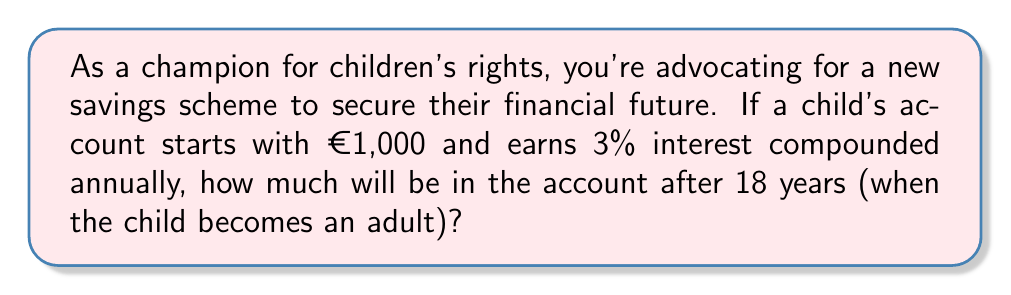Give your solution to this math problem. To solve this problem, we'll use the compound interest formula:

$$ A = P(1 + r)^n $$

Where:
$A$ = final amount
$P$ = principal (initial investment)
$r$ = annual interest rate (in decimal form)
$n$ = number of years

Given:
$P = €1,000$
$r = 3\% = 0.03$
$n = 18$ years

Let's substitute these values into the formula:

$$ A = 1000(1 + 0.03)^{18} $$

Now, let's calculate step-by-step:

1) First, calculate $(1 + 0.03)$:
   $1 + 0.03 = 1.03$

2) Now, we need to calculate $1.03^{18}$:
   $1.03^{18} \approx 1.7017$ (rounded to 4 decimal places)

3) Finally, multiply this by the initial amount:
   $1000 \times 1.7017 \approx 1701.70$

Therefore, after 18 years, the account will contain approximately €1,701.70.
Answer: €1,701.70 